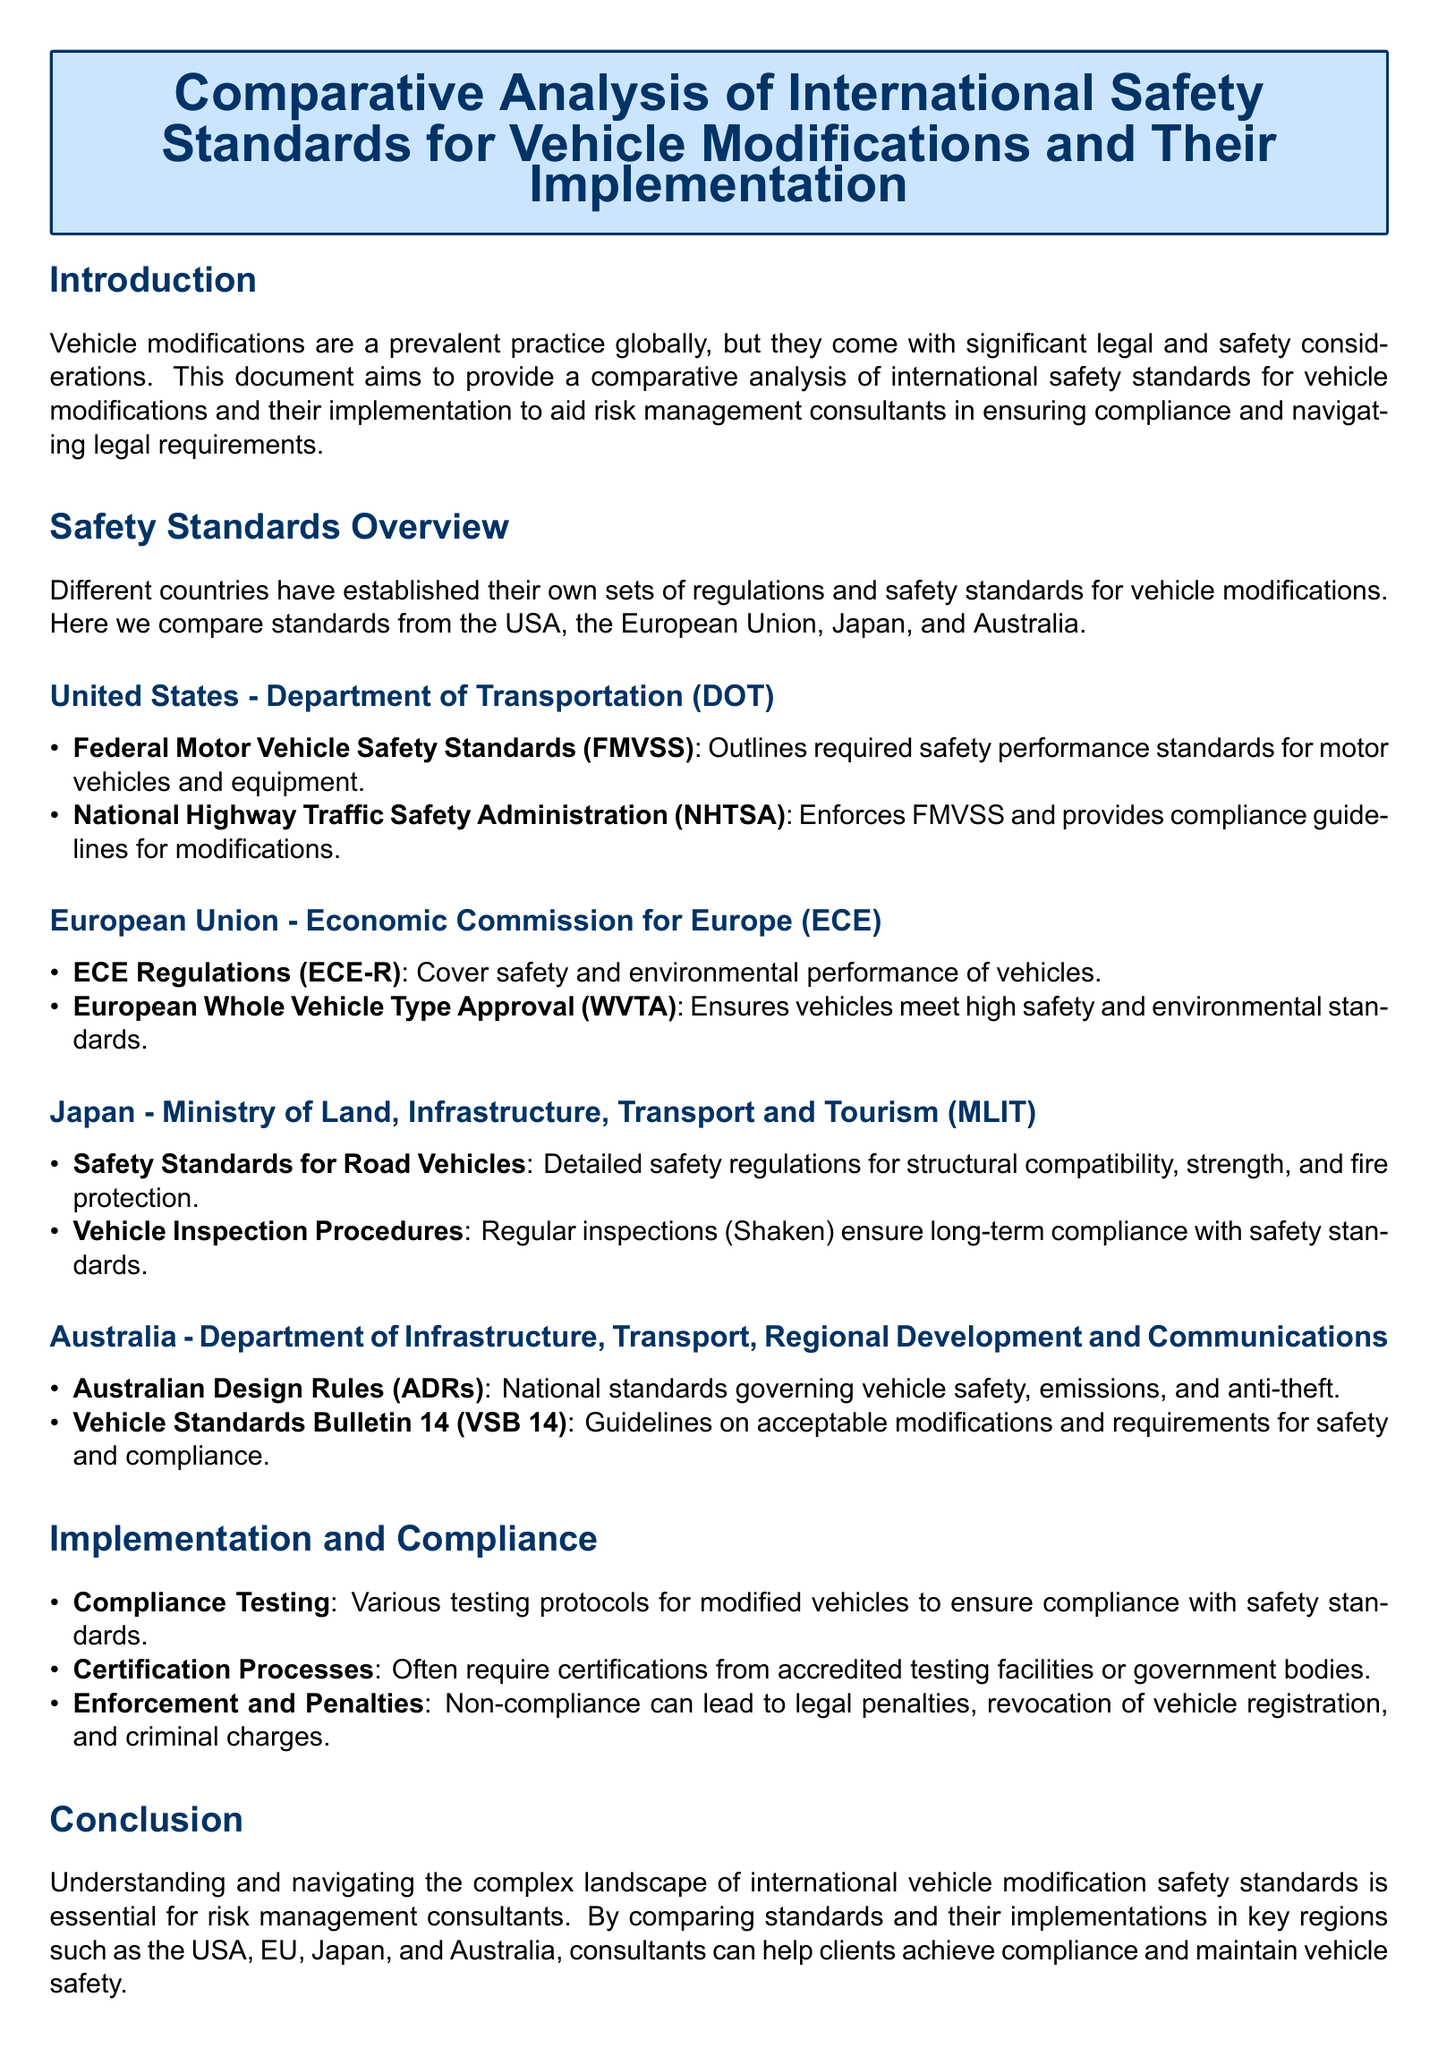What organization enforces FMVSS in the USA? The National Highway Traffic Safety Administration (NHTSA) enforces FMVSS in the USA.
Answer: NHTSA What does ECE-R stand for? ECE-R refers to Economic Commission for Europe Regulations.
Answer: ECE Regulations Which country's safety standards include regular inspections known as Shaken? Japan's Ministry of Land, Infrastructure, Transport and Tourism includes regular inspections known as Shaken.
Answer: Japan What are the Australian standards governing vehicle safety referred to? The Australian Design Rules (ADRs) govern vehicle safety in Australia.
Answer: Australian Design Rules What is the impact of non-compliance with vehicle modification standards? Non-compliance can lead to legal penalties, revocation of vehicle registration, and criminal charges.
Answer: Legal penalties Which key regions are compared for vehicle modification standards? The USA, EU, Japan, and Australia are the key regions compared for vehicle modification standards.
Answer: USA, EU, Japan, Australia How does the document categorize safety regulations? Regulations are categorized by country, detailing standards and implementation for vehicle modifications.
Answer: By country What is the primary purpose of the document? The primary purpose is to aid risk management consultants in ensuring compliance and navigating legal requirements for vehicle modifications.
Answer: Aid risk management consultants 